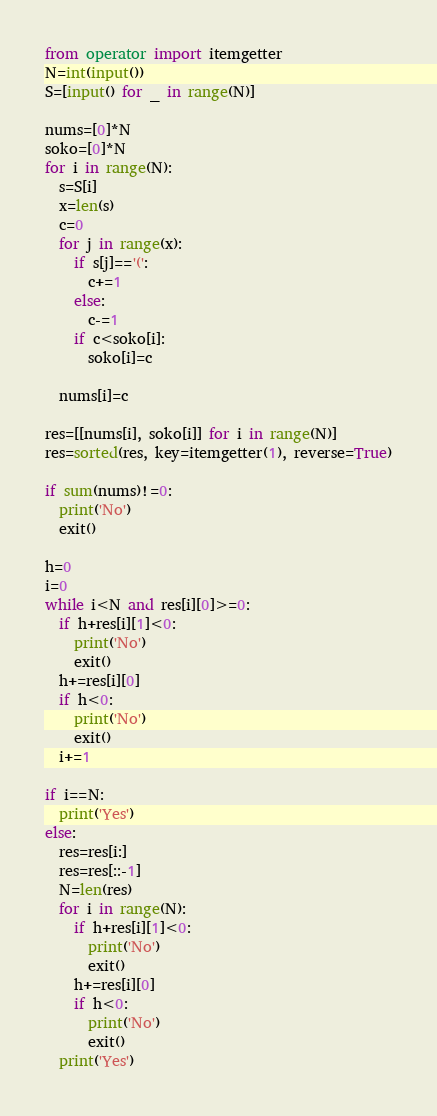<code> <loc_0><loc_0><loc_500><loc_500><_Python_>from operator import itemgetter
N=int(input())
S=[input() for _ in range(N)]

nums=[0]*N
soko=[0]*N
for i in range(N):
  s=S[i]
  x=len(s)
  c=0
  for j in range(x):
    if s[j]=='(':
      c+=1
    else:
      c-=1
    if c<soko[i]:
      soko[i]=c
  
  nums[i]=c
  
res=[[nums[i], soko[i]] for i in range(N)]
res=sorted(res, key=itemgetter(1), reverse=True)

if sum(nums)!=0:
  print('No')
  exit()
  
h=0
i=0
while i<N and res[i][0]>=0:
  if h+res[i][1]<0:
    print('No')
    exit()
  h+=res[i][0]
  if h<0:
    print('No')
    exit()
  i+=1
  
if i==N:
  print('Yes')
else:
  res=res[i:]
  res=res[::-1]
  N=len(res)
  for i in range(N):
    if h+res[i][1]<0:
      print('No')
      exit()
    h+=res[i][0]
    if h<0:
      print('No')
      exit()
  print('Yes')</code> 